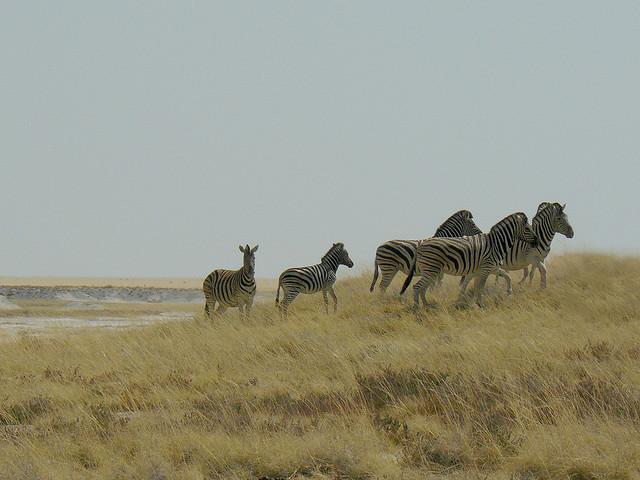How many animals?
Give a very brief answer. 5. How many zebra?
Give a very brief answer. 5. How many zebras can you see?
Give a very brief answer. 5. 